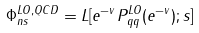<formula> <loc_0><loc_0><loc_500><loc_500>\Phi _ { n s } ^ { L O , Q C D } = L [ { { e } ^ { - v } } P _ { q q } ^ { L O } ( { { e } ^ { - v } } ) ; s ]</formula> 